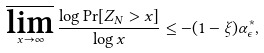Convert formula to latex. <formula><loc_0><loc_0><loc_500><loc_500>\varlimsup _ { x \rightarrow \infty } \frac { \log \Pr [ Z _ { N } > x ] } { \log x } \leq - ( 1 - \xi ) \alpha ^ { \ast } _ { \epsilon } ,</formula> 